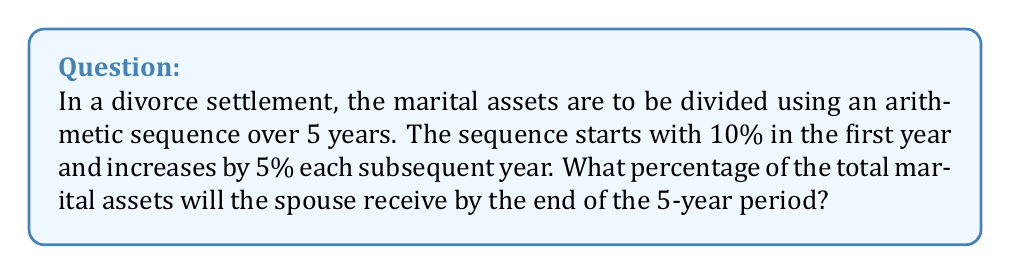Show me your answer to this math problem. Let's approach this step-by-step:

1) The arithmetic sequence is defined as:
   $a_n = a_1 + (n-1)d$
   Where $a_1$ is the first term, $n$ is the term number, and $d$ is the common difference.

2) We know:
   $a_1 = 10\%$ (first year)
   $d = 5\%$ (increase each year)
   $n = 5$ (5-year period)

3) Let's calculate each year's percentage:
   Year 1: $a_1 = 10\%$
   Year 2: $a_2 = 10\% + 5\% = 15\%$
   Year 3: $a_3 = 10\% + 2(5\%) = 20\%$
   Year 4: $a_4 = 10\% + 3(5\%) = 25\%$
   Year 5: $a_5 = 10\% + 4(5\%) = 30\%$

4) To find the total, we need to sum these percentages. We can use the arithmetic sequence sum formula:
   
   $$S_n = \frac{n}{2}(a_1 + a_n)$$

   Where $S_n$ is the sum of $n$ terms, $a_1$ is the first term, and $a_n$ is the last term.

5) Plugging in our values:
   
   $$S_5 = \frac{5}{2}(10\% + 30\%) = \frac{5}{2}(40\%) = 100\%$$

Therefore, the spouse will receive 100% of the total marital assets by the end of the 5-year period.
Answer: 100% 